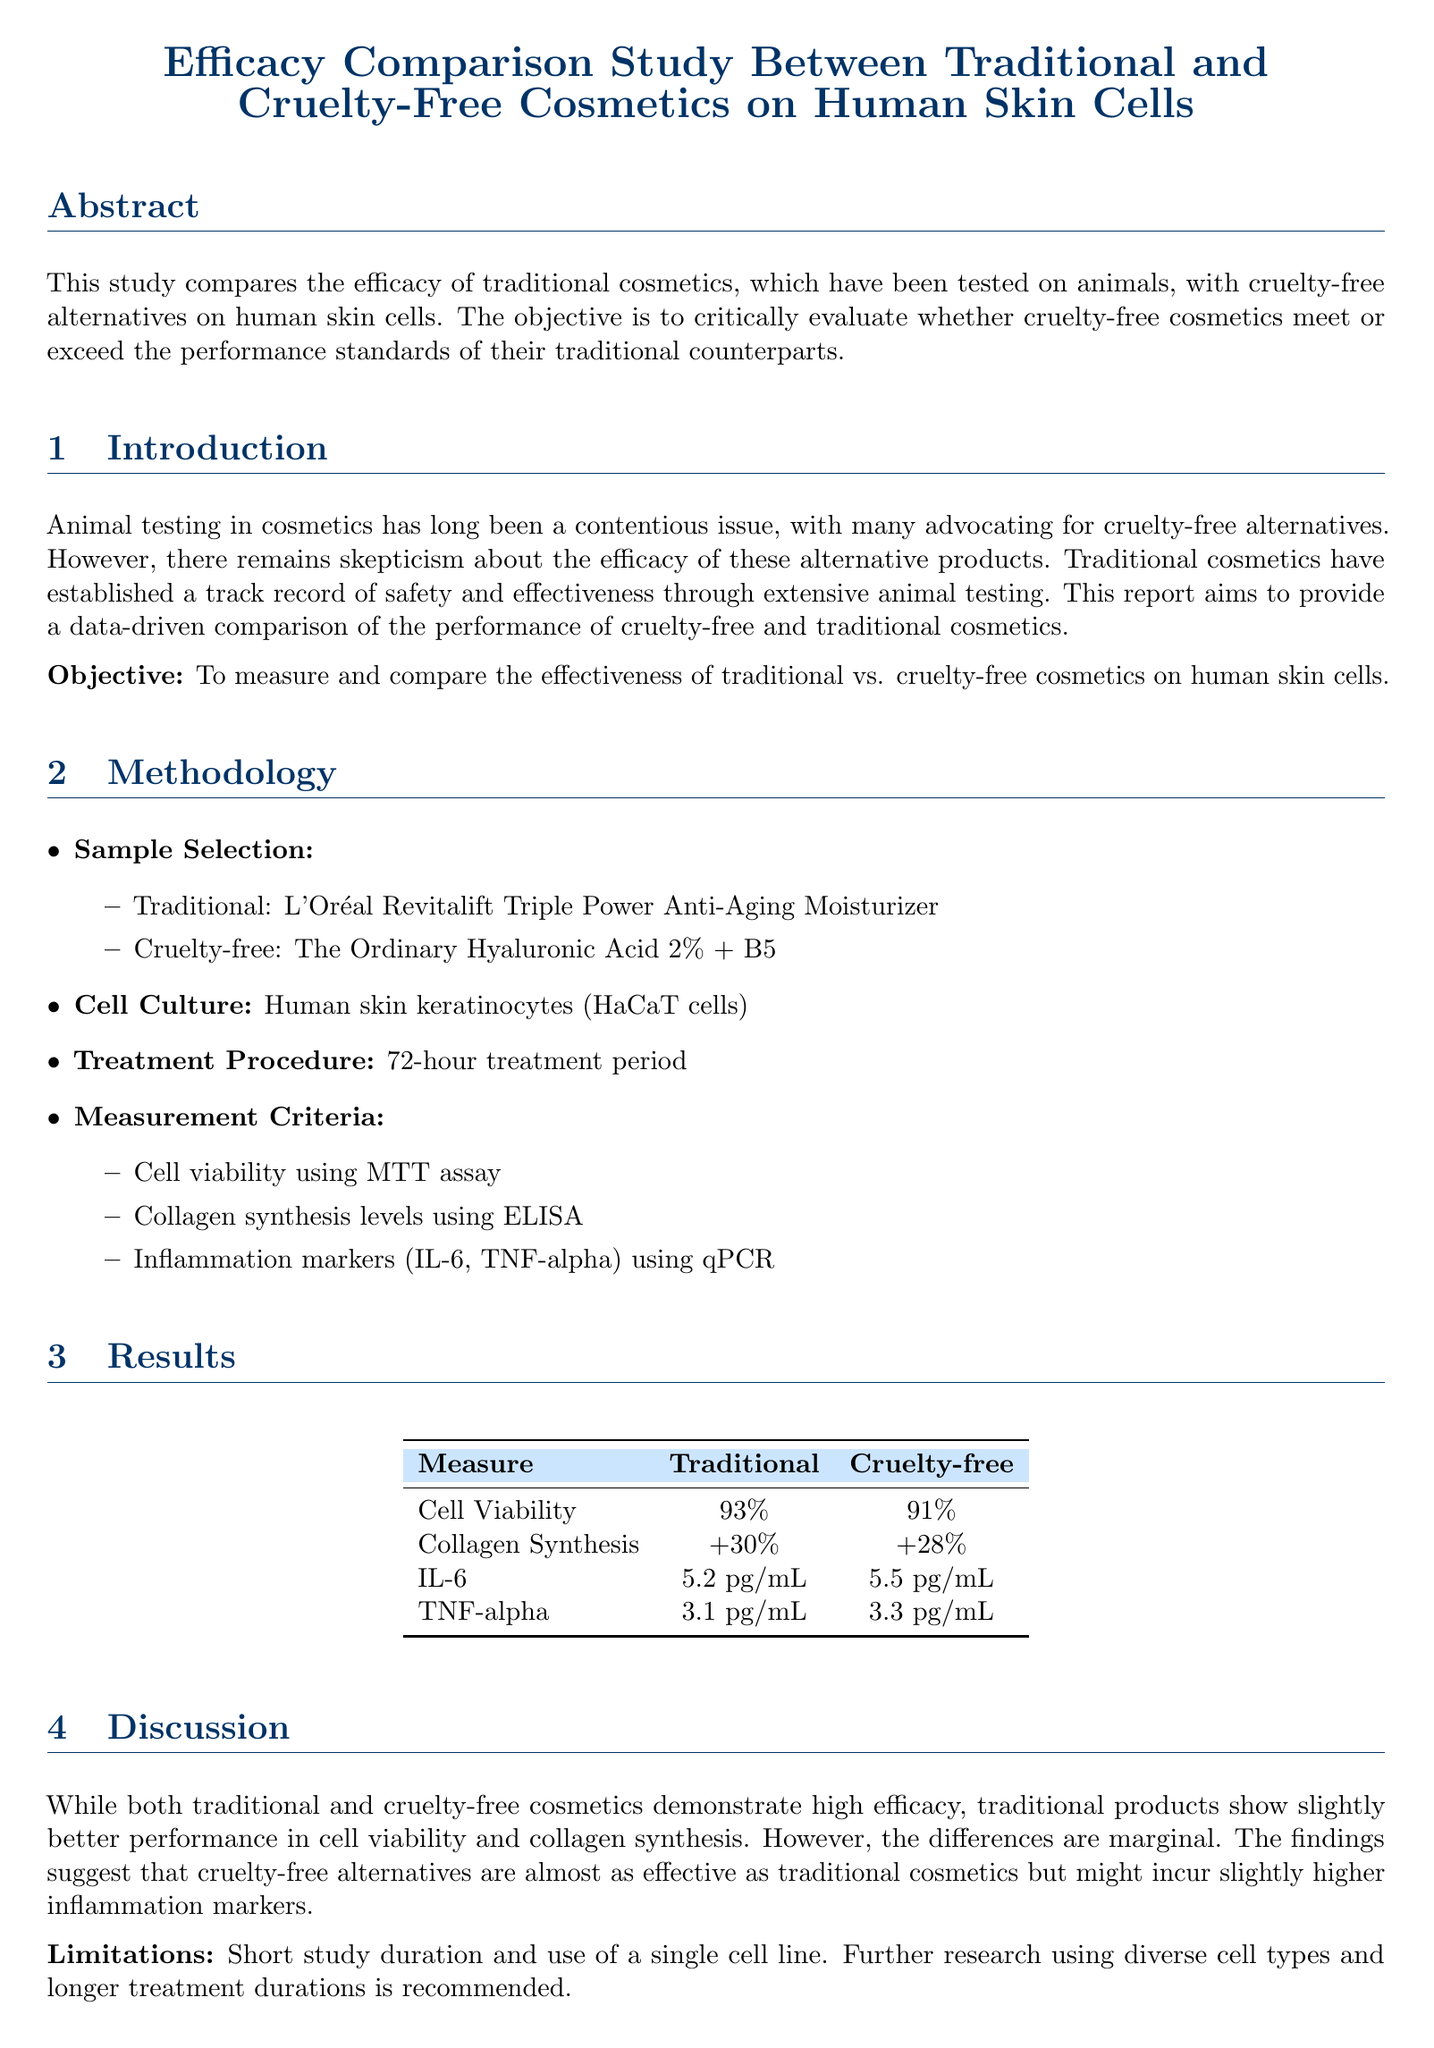What is the aim of the study? The aim is to measure and compare the effectiveness of traditional vs. cruelty-free cosmetics on human skin cells.
Answer: To measure and compare the effectiveness of traditional vs. cruelty-free cosmetics on human skin cells What is the cell line used in the study? The study used human skin keratinocytes (HaCaT cells) as the cell line.
Answer: Human skin keratinocytes (HaCaT cells) Which traditional cosmetic product was tested? The traditional cosmetic product tested was L'Oréal Revitalift Triple Power Anti-Aging Moisturizer.
Answer: L'Oréal Revitalift Triple Power Anti-Aging Moisturizer What was the percentage of cell viability for cruelty-free cosmetics? The cell viability for cruelty-free cosmetics was measured at 91%.
Answer: 91% What is one limitation mentioned in the study? One limitation mentioned is the short study duration.
Answer: Short study duration Which inflammation marker had a higher level in cruelty-free cosmetics? The inflammation marker with a higher level was TNF-alpha, measured at 3.3 pg/mL.
Answer: TNF-alpha How long was the treatment period? The treatment period lasted for 72 hours.
Answer: 72 hours What was the collagen synthesis increase for traditional cosmetics? The increase in collagen synthesis for traditional cosmetics was +30%.
Answer: +30% 